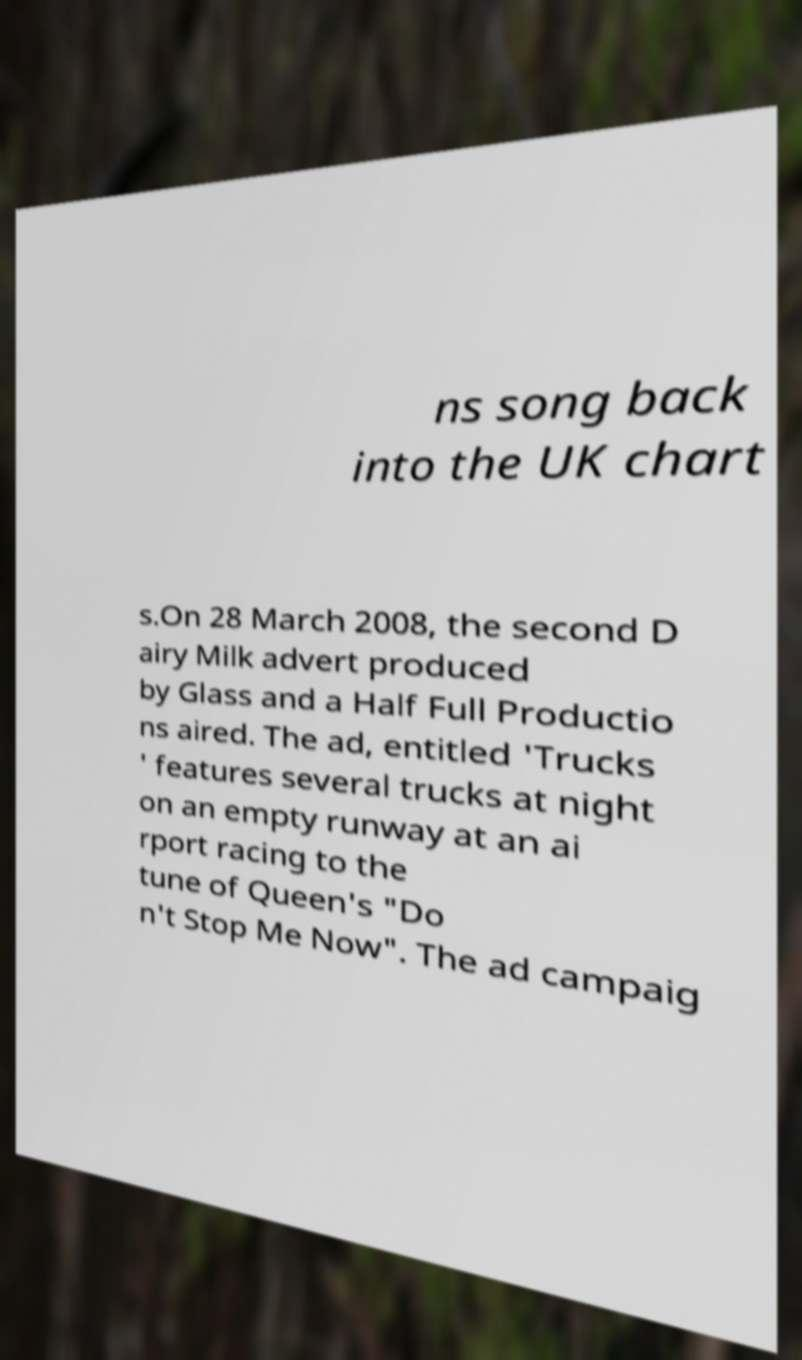Please read and relay the text visible in this image. What does it say? ns song back into the UK chart s.On 28 March 2008, the second D airy Milk advert produced by Glass and a Half Full Productio ns aired. The ad, entitled 'Trucks ' features several trucks at night on an empty runway at an ai rport racing to the tune of Queen's "Do n't Stop Me Now". The ad campaig 